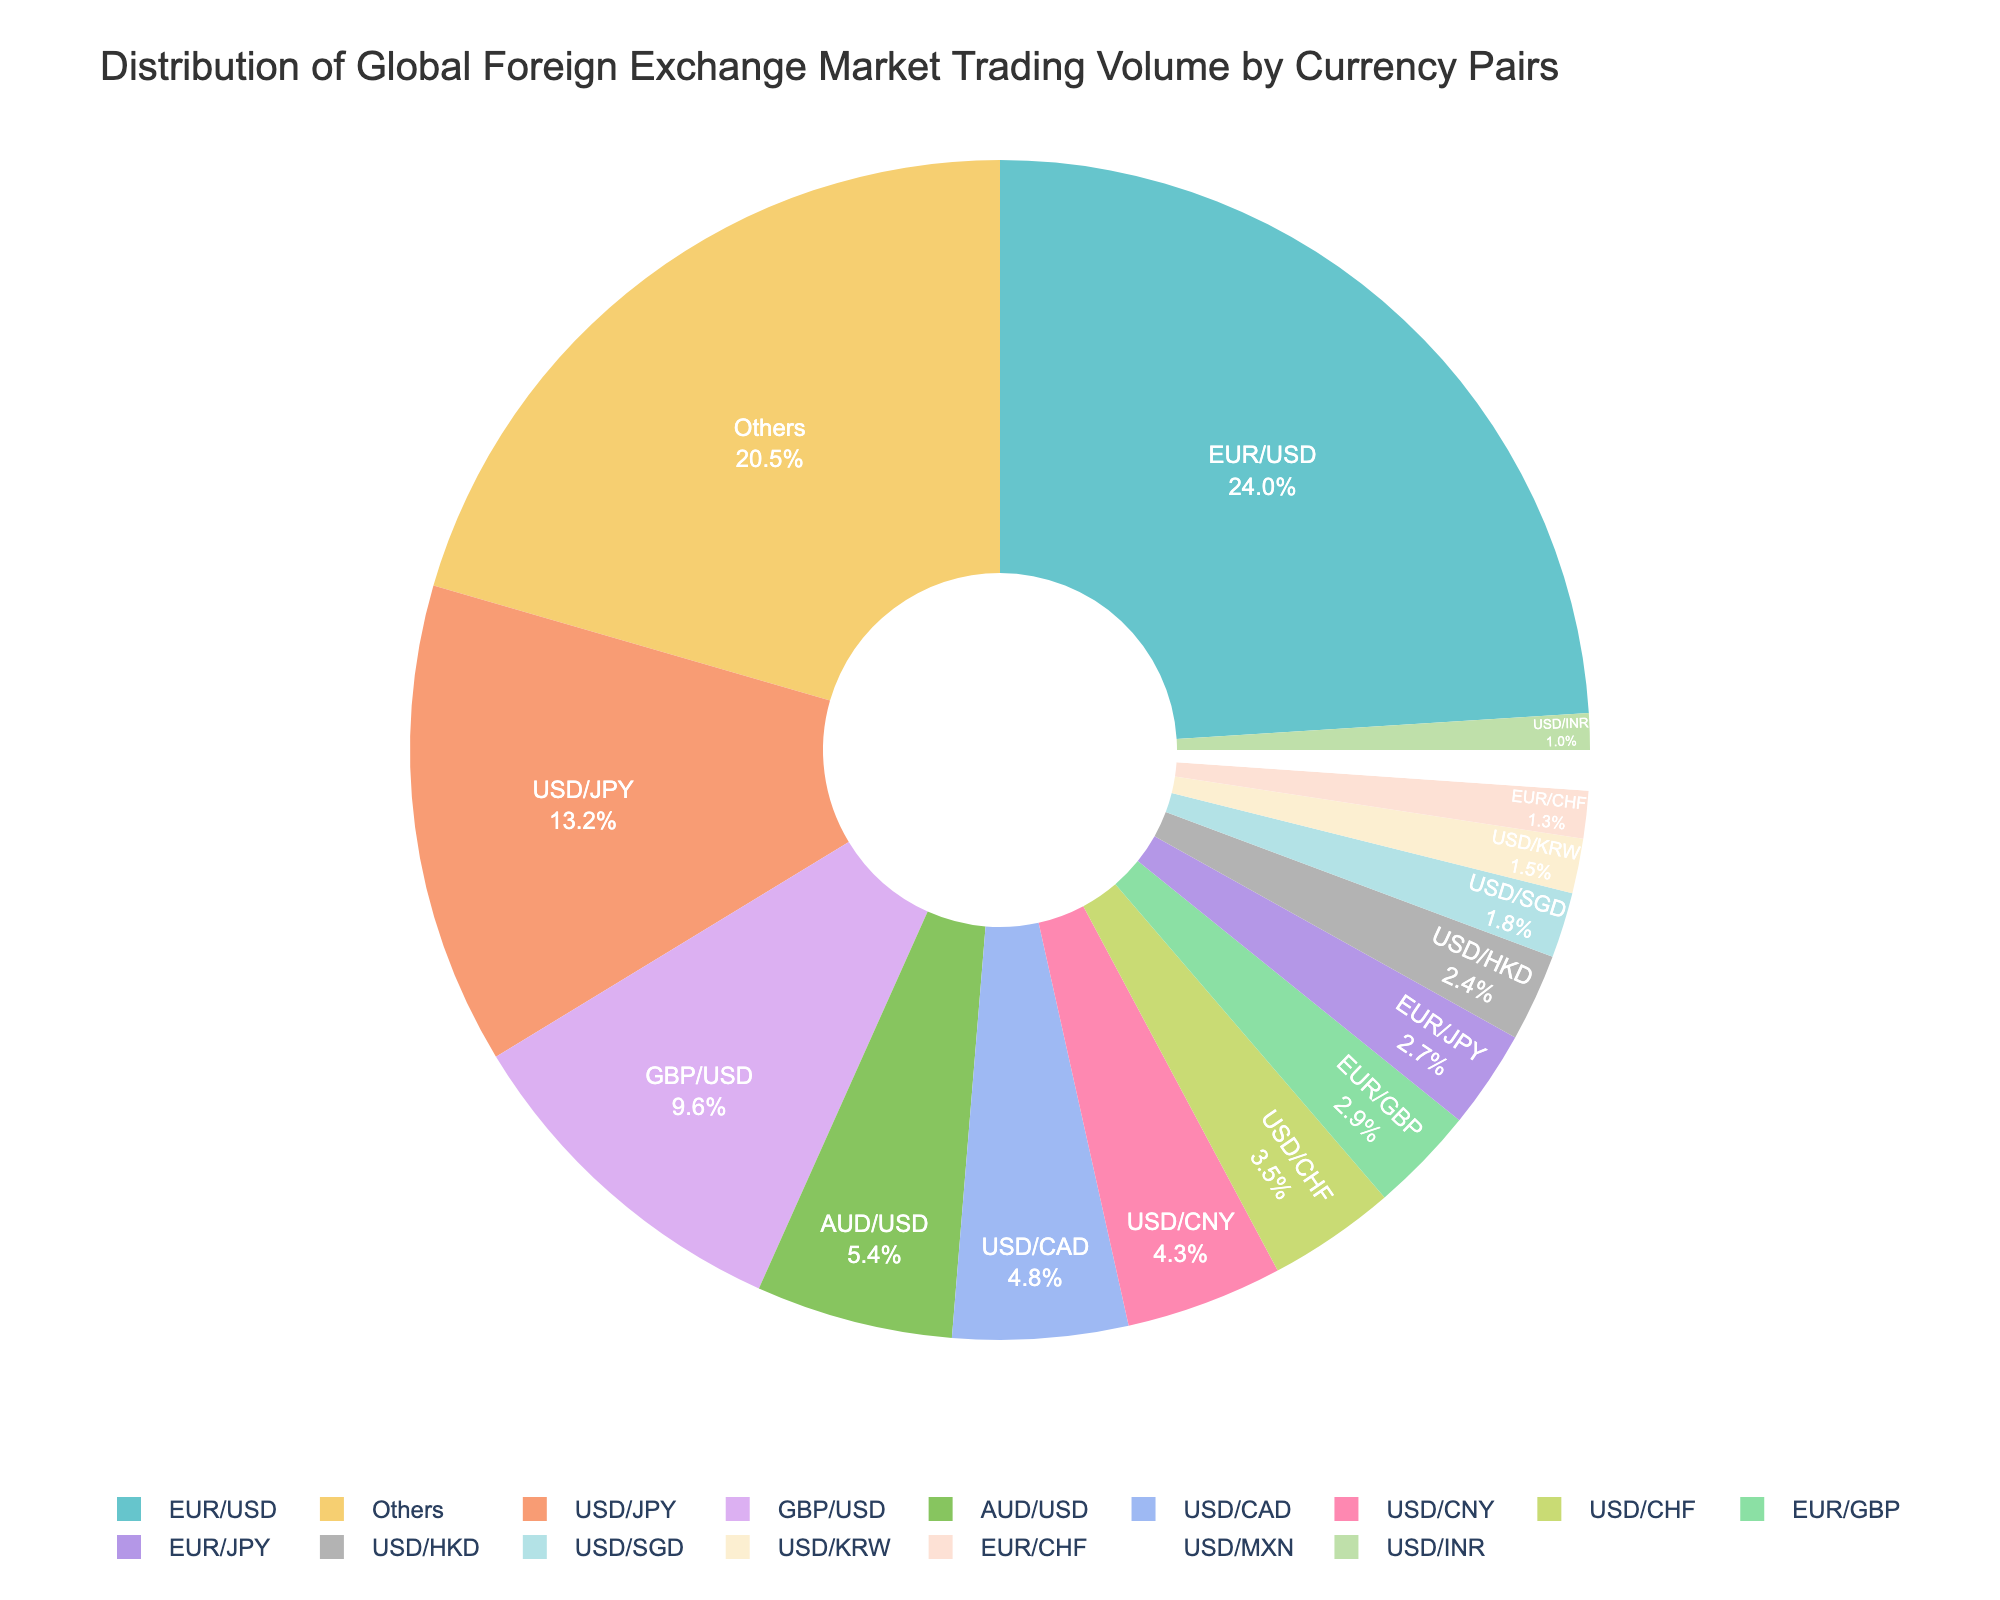What percentage of the global foreign exchange market trading volume is accounted for by EUR/USD and USD/JPY combined? EUR/USD contributes 24.0% and USD/JPY contributes 13.2%. Adding these percentages: 24.0% + 13.2% = 37.2%
Answer: 37.2% Which currency pair has a greater trading volume, GBP/USD or AUD/USD? GBP/USD has a trading volume of 9.6% and AUD/USD has a trading volume of 5.4%. Comparing these, 9.6% is greater than 5.4%
Answer: GBP/USD What is the third most traded currency pair based on the pie chart? From the data and the pie chart, the third highest trading volume is GBP/USD with 9.6%
Answer: GBP/USD Is the trading volume of USD/CAD higher or lower than USD/CNY? USD/CAD has a trading volume of 4.8% and USD/CNY has a trading volume of 4.3%. Since 4.8% is greater than 4.3%, USD/CAD has a higher trading volume
Answer: Higher What is the total trading volume percentage of currency pairs involving EUR (EUR/USD, EUR/GBP, EUR/JPY, EUR/CHF)? Summing up the trading volumes: EUR/USD (24.0%), EUR/GBP (2.9%), EUR/JPY (2.7%), EUR/CHF (1.3%): 24.0% + 2.9% + 2.7% + 1.3% = 30.9%
Answer: 30.9% Among the currency pairs involving USD, which pair has the smallest trading volume? From the data, USD/INR has the smallest trading volume of 1.0% among the USD pairs
Answer: USD/INR How does the trading volume of USD/HKD compare to USD/SGD? USD/HKD has a trading volume of 2.4% and USD/SGD has a trading volume of 1.8%. Thus, USD/HKD has a larger trading volume than USD/SGD
Answer: USD/HKD Which four currency pairs combined constitute approximately half of the total trading volume? From the highest to lowest percentages: EUR/USD (24.0%), USD/JPY (13.2%), GBP/USD (9.6%), AUD/USD (5.4%). Summing these: 24.0% + 13.2% + 9.6% + 5.4% = 52.2%
Answer: EUR/USD, USD/JPY, GBP/USD, AUD/USD What percentage of the total trading volume is captured by the "Others" category? The "Others" category captures 20.5% of the total trading volume as indicated by the pie chart
Answer: 20.5% 